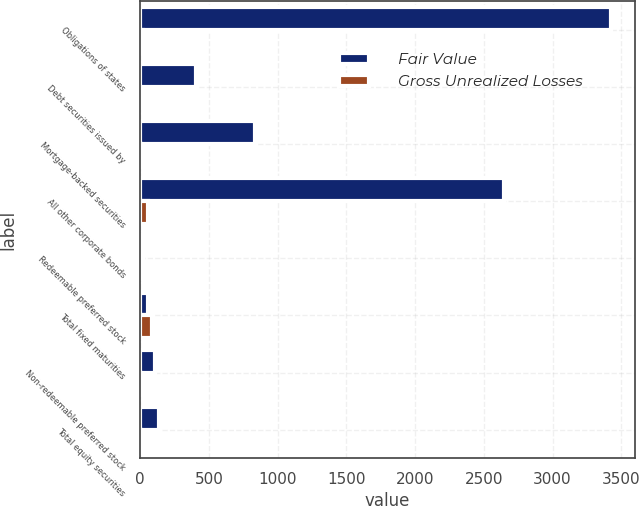Convert chart. <chart><loc_0><loc_0><loc_500><loc_500><stacked_bar_chart><ecel><fcel>Obligations of states<fcel>Debt securities issued by<fcel>Mortgage-backed securities<fcel>All other corporate bonds<fcel>Redeemable preferred stock<fcel>Total fixed maturities<fcel>Non-redeemable preferred stock<fcel>Total equity securities<nl><fcel>Fair Value<fcel>3428<fcel>409<fcel>838<fcel>2646<fcel>19<fcel>55<fcel>110<fcel>139<nl><fcel>Gross Unrealized Losses<fcel>23<fcel>1<fcel>5<fcel>55<fcel>1<fcel>85<fcel>9<fcel>10<nl></chart> 